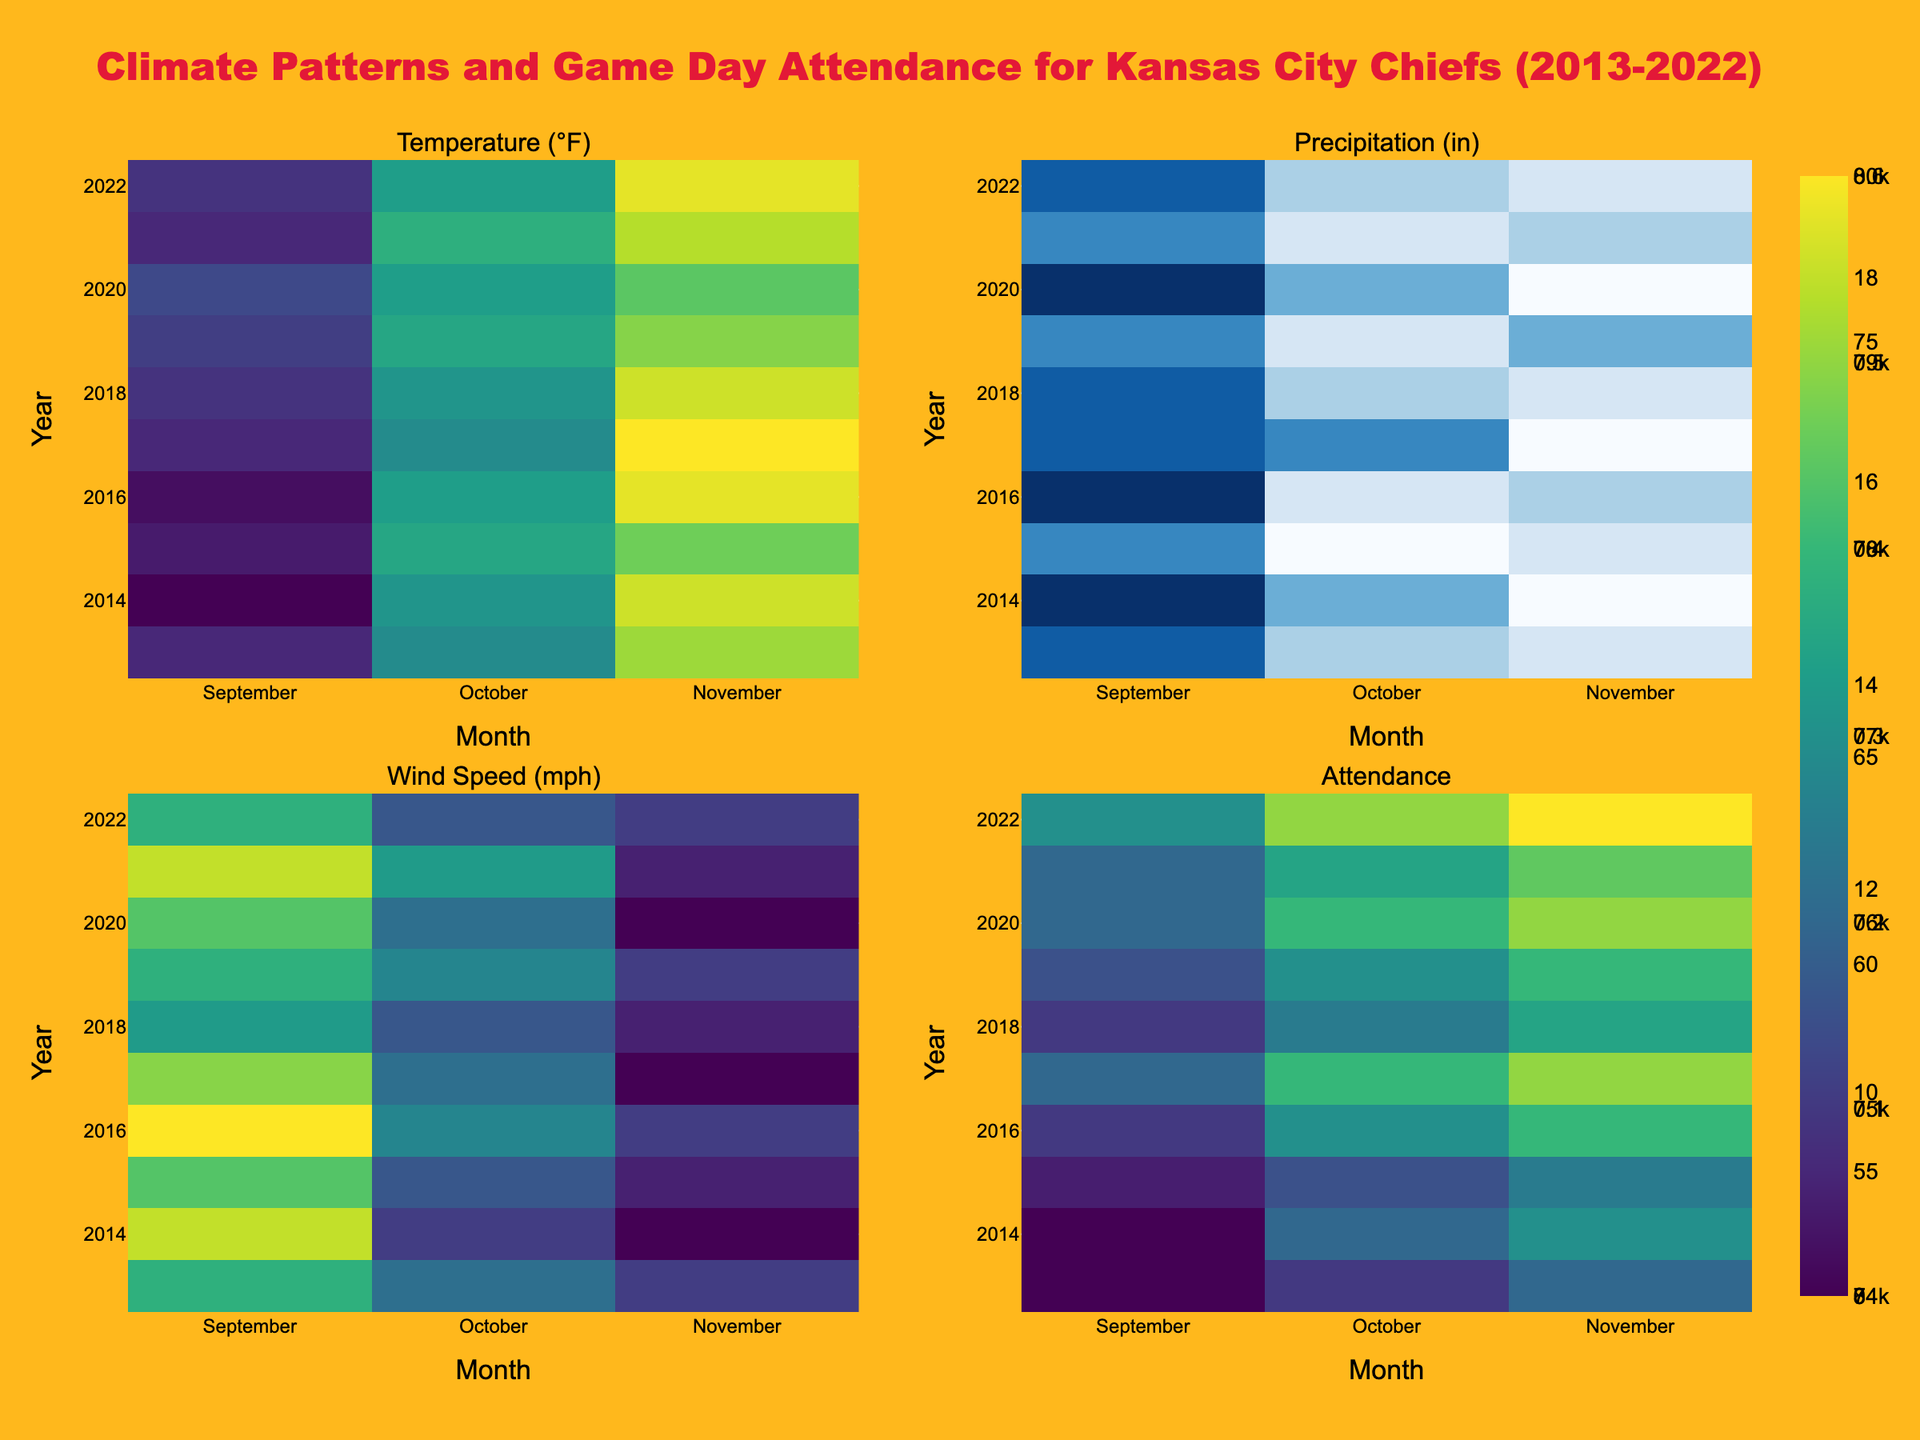What is the general trend of game day attendance from 2013 to 2022? Looking at the heatmap for Attendance, you can observe that the color intensity (indicative of higher attendance) generally increases over the years. This suggests an upward trend in the game day attendance over the decade.
Answer: Upward trend Which month usually sees the highest temperatures for Kansas City Chiefs games? The heatmap for Temperature (°F) shows the highest intensity (darkest color) for September consistently across all years.
Answer: September What is the relationship between wind speed and attendance in November? Observing the heatmaps for Wind Speed and Attendance, when wind speeds are higher (e.g., 2014, 2016), the attendance tends to be lower compared to other months. This indicates a possible inverse relationship.
Answer: Inverse relationship How does precipitation affect attendance in October across the years? Examining the heatmaps for Precipitation and Attendance in October, there's no clear pattern of attendance dropping on higher precipitation days, suggesting the impact might be minimal.
Answer: Minimal impact Which year had the highest average temperature in September? For this, you need to look at the September column in the Temperature heatmap. The darkest color (indicating highest temperature) is in 2017.
Answer: 2017 Compare the attendance in October between 2013 and 2022. Which year had higher attendance? By comparing the color intensities in the Attendance heatmap for October, 2022 shows a higher intensity/darker color than 2013, indicating higher attendance in 2022.
Answer: 2022 What can be inferred about the attendance when both temperature and wind speed are high? From the heatmaps, when both temperature and wind speed are high, such as in September 2022 and November 2022, the attendance remains relatively high. This suggests that high temperatures might off-set the effect of high wind speeds on attendance.
Answer: Attendance remains high Which month exhibits the most variation in precipitation levels, and how might this impact attendance? Observing the precipitation heatmap, October shows a lot of variation in colors, indicating various precipitation levels. However, attendance in October remains relatively consistent, implying the variation in precipitation does not significantly affect attendance.
Answer: October; No significant impact 